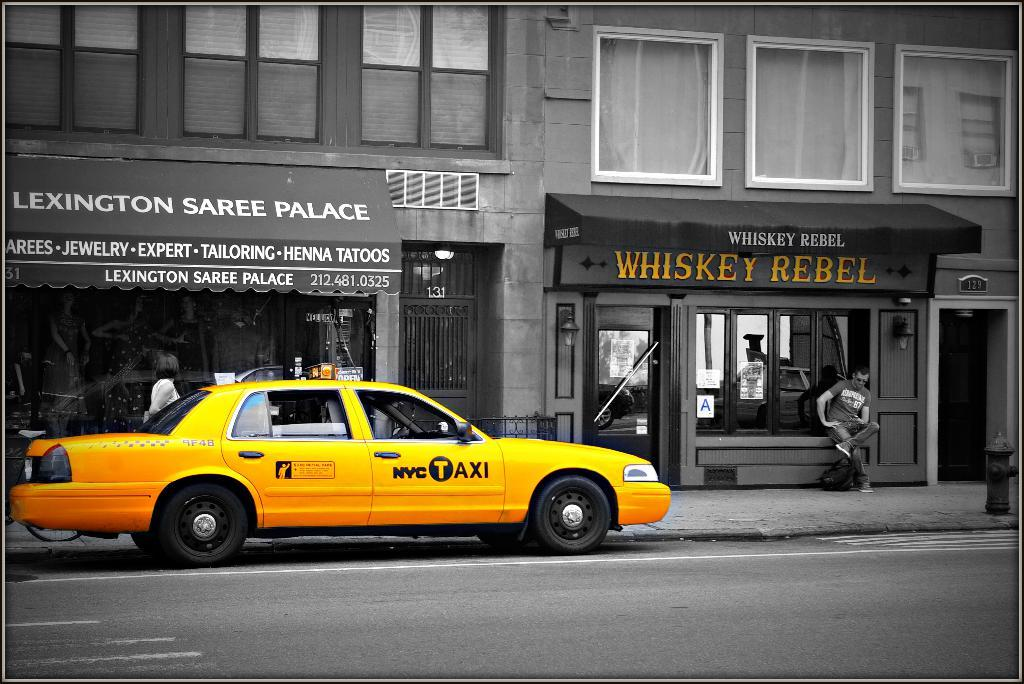<image>
Render a clear and concise summary of the photo. A taxi passes near a storefront called Whiskey Rebel. 